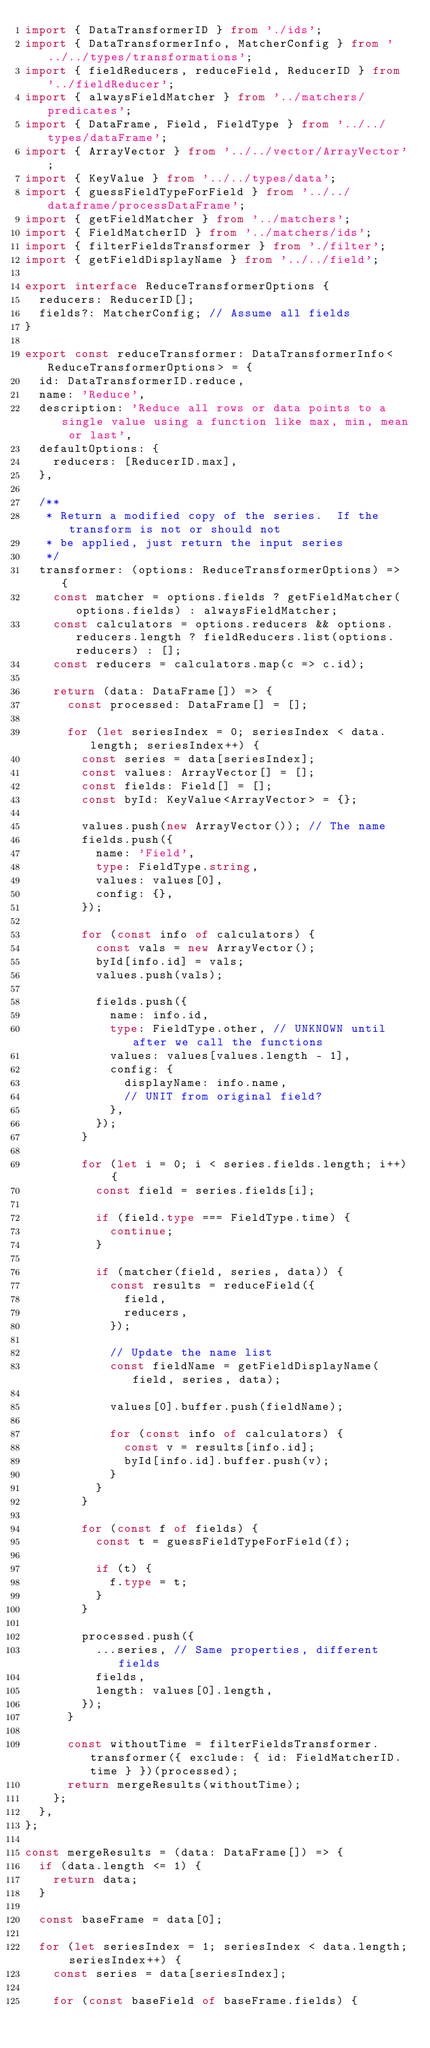Convert code to text. <code><loc_0><loc_0><loc_500><loc_500><_TypeScript_>import { DataTransformerID } from './ids';
import { DataTransformerInfo, MatcherConfig } from '../../types/transformations';
import { fieldReducers, reduceField, ReducerID } from '../fieldReducer';
import { alwaysFieldMatcher } from '../matchers/predicates';
import { DataFrame, Field, FieldType } from '../../types/dataFrame';
import { ArrayVector } from '../../vector/ArrayVector';
import { KeyValue } from '../../types/data';
import { guessFieldTypeForField } from '../../dataframe/processDataFrame';
import { getFieldMatcher } from '../matchers';
import { FieldMatcherID } from '../matchers/ids';
import { filterFieldsTransformer } from './filter';
import { getFieldDisplayName } from '../../field';

export interface ReduceTransformerOptions {
  reducers: ReducerID[];
  fields?: MatcherConfig; // Assume all fields
}

export const reduceTransformer: DataTransformerInfo<ReduceTransformerOptions> = {
  id: DataTransformerID.reduce,
  name: 'Reduce',
  description: 'Reduce all rows or data points to a single value using a function like max, min, mean or last',
  defaultOptions: {
    reducers: [ReducerID.max],
  },

  /**
   * Return a modified copy of the series.  If the transform is not or should not
   * be applied, just return the input series
   */
  transformer: (options: ReduceTransformerOptions) => {
    const matcher = options.fields ? getFieldMatcher(options.fields) : alwaysFieldMatcher;
    const calculators = options.reducers && options.reducers.length ? fieldReducers.list(options.reducers) : [];
    const reducers = calculators.map(c => c.id);

    return (data: DataFrame[]) => {
      const processed: DataFrame[] = [];

      for (let seriesIndex = 0; seriesIndex < data.length; seriesIndex++) {
        const series = data[seriesIndex];
        const values: ArrayVector[] = [];
        const fields: Field[] = [];
        const byId: KeyValue<ArrayVector> = {};

        values.push(new ArrayVector()); // The name
        fields.push({
          name: 'Field',
          type: FieldType.string,
          values: values[0],
          config: {},
        });

        for (const info of calculators) {
          const vals = new ArrayVector();
          byId[info.id] = vals;
          values.push(vals);

          fields.push({
            name: info.id,
            type: FieldType.other, // UNKNOWN until after we call the functions
            values: values[values.length - 1],
            config: {
              displayName: info.name,
              // UNIT from original field?
            },
          });
        }

        for (let i = 0; i < series.fields.length; i++) {
          const field = series.fields[i];

          if (field.type === FieldType.time) {
            continue;
          }

          if (matcher(field, series, data)) {
            const results = reduceField({
              field,
              reducers,
            });

            // Update the name list
            const fieldName = getFieldDisplayName(field, series, data);

            values[0].buffer.push(fieldName);

            for (const info of calculators) {
              const v = results[info.id];
              byId[info.id].buffer.push(v);
            }
          }
        }

        for (const f of fields) {
          const t = guessFieldTypeForField(f);

          if (t) {
            f.type = t;
          }
        }

        processed.push({
          ...series, // Same properties, different fields
          fields,
          length: values[0].length,
        });
      }

      const withoutTime = filterFieldsTransformer.transformer({ exclude: { id: FieldMatcherID.time } })(processed);
      return mergeResults(withoutTime);
    };
  },
};

const mergeResults = (data: DataFrame[]) => {
  if (data.length <= 1) {
    return data;
  }

  const baseFrame = data[0];

  for (let seriesIndex = 1; seriesIndex < data.length; seriesIndex++) {
    const series = data[seriesIndex];

    for (const baseField of baseFrame.fields) {</code> 